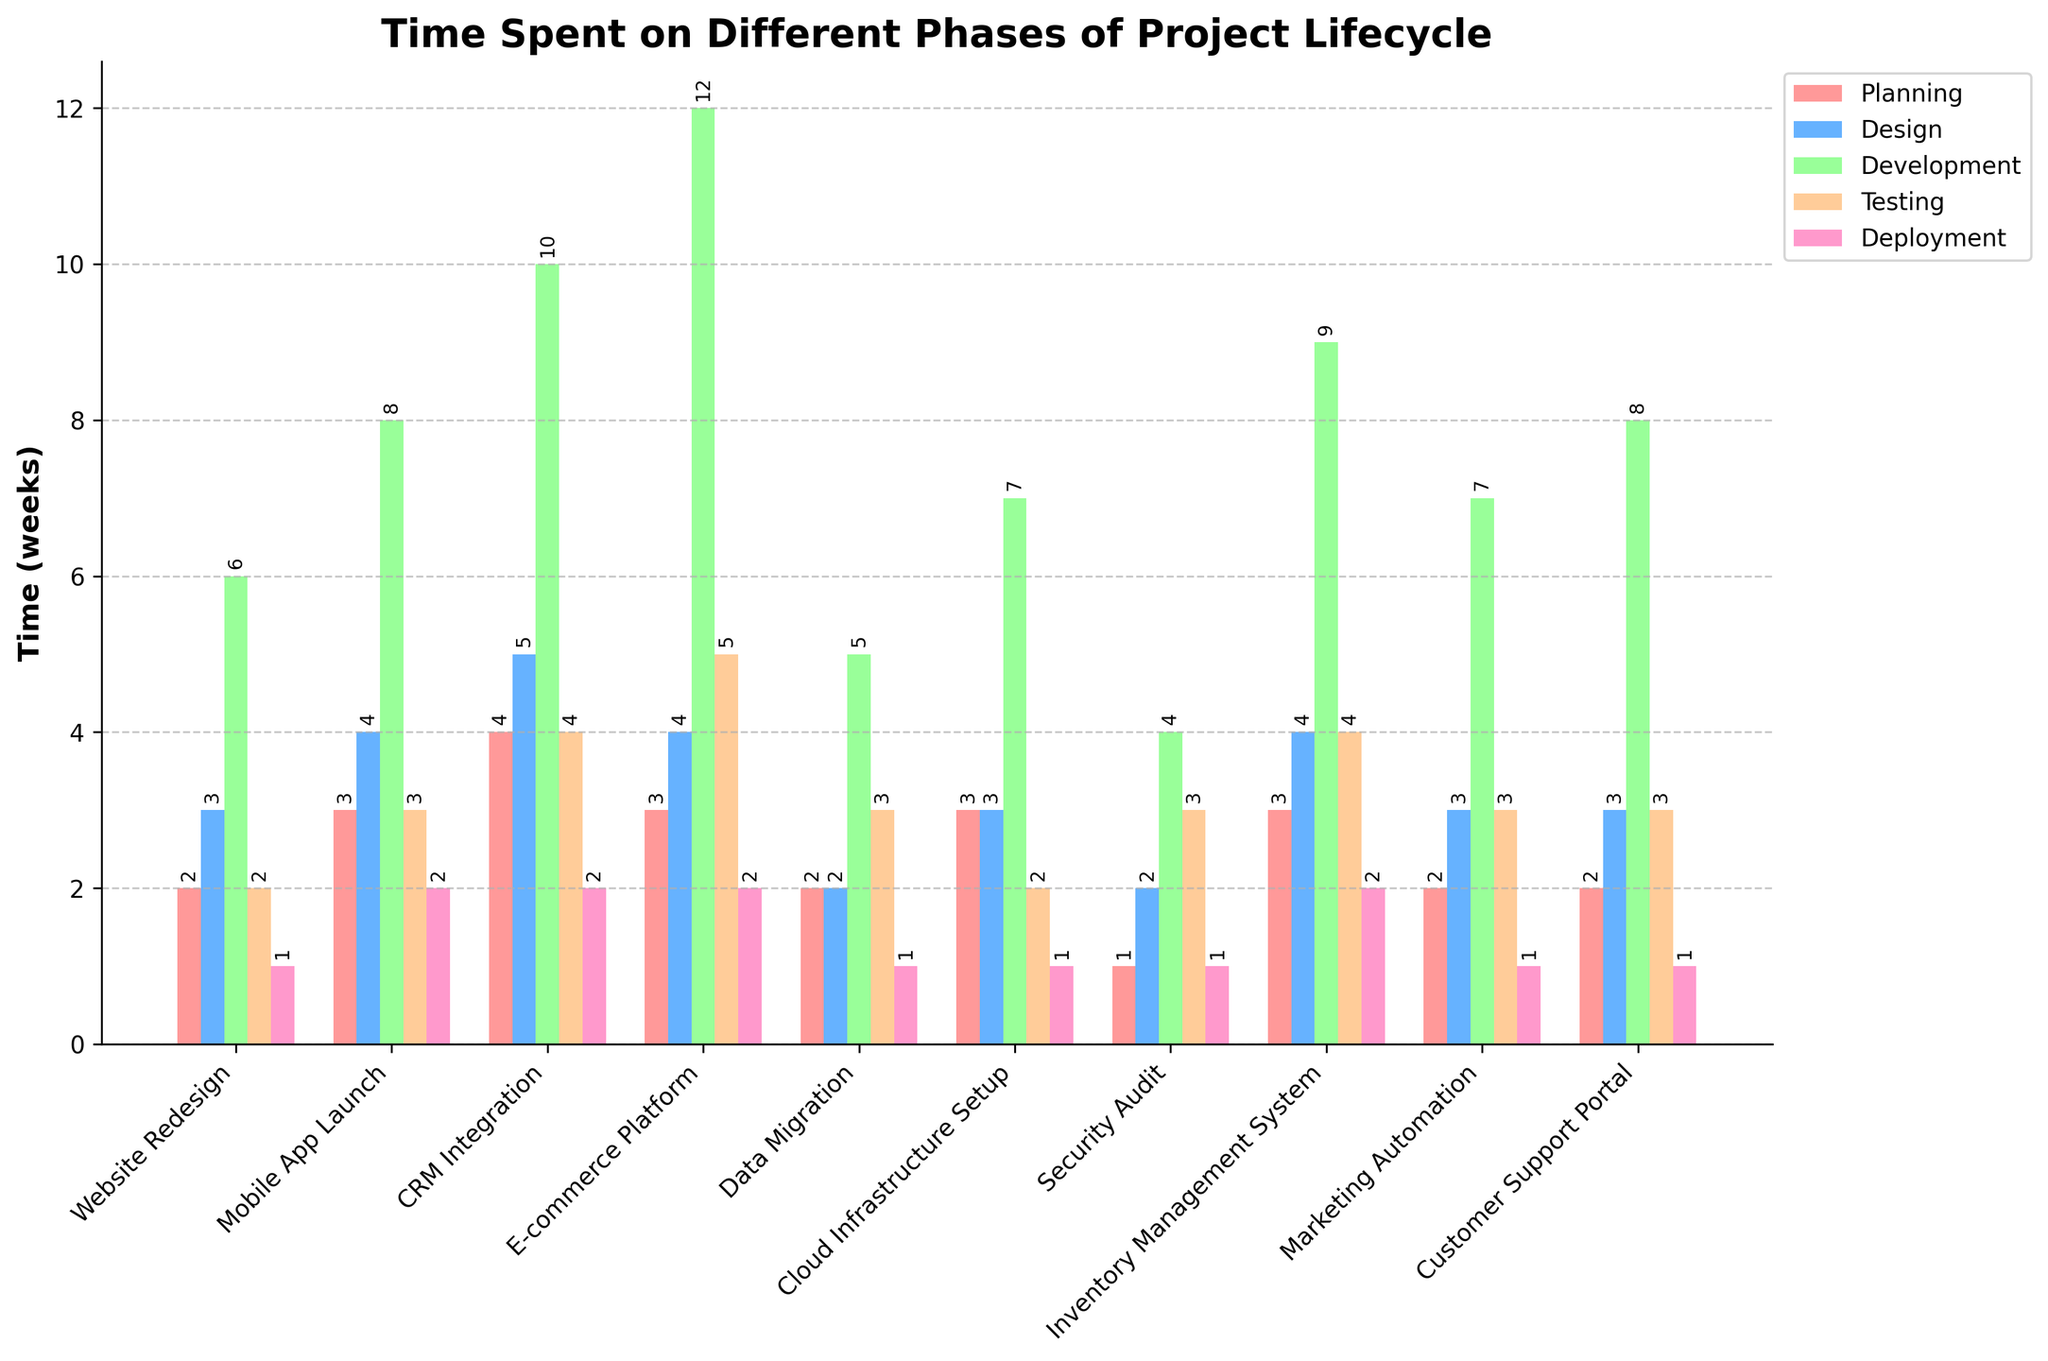What's the average time spent on the Development phase across all projects? First, sum the time spent on the Development phase for each project: 6 + 8 + 10 + 12 + 5 + 7 + 4 + 9 + 7 + 8 = 76. There are 10 projects, so we divide the total by 10. The average is 76/10 = 7.6 weeks.
Answer: 7.6 weeks Which project spent the most time on the Testing phase? By looking at the heights of the bars for the Testing phase, the project 'E-commerce Platform' has the tallest bar at 5 weeks.
Answer: E-commerce Platform How does the time spent on Deployment compare between 'Website Redesign' and 'Mobile App Launch'? The height of the Deployment bar for 'Website Redesign' is 1 week, and for 'Mobile App Launch' it is 2 weeks. So, 'Mobile App Launch' spent 1 week more on Deployment.
Answer: Mobile App Launch spent 1 week more Which phase has the most consistent time spent across all projects? By observing the bars, the Deployment phase has the most consistent height across all projects, varying between 1 and 2 weeks.
Answer: Deployment How many weeks were spent on the Planning phase for projects that also spent more than 3 weeks on the Testing phase? Projects 'CRM Integration' (4+5=9 weeks), 'E-commerce Platform' (3+5=8 weeks), and 'Inventory Management System' (3+4=7 weeks) spent more than 3 weeks on Testing. Summing the Planning times for these projects: 4 + 3 + 3 = 10 weeks.
Answer: 10 weeks What's the total time spent on 'Cloud Infrastructure Setup'? Add the time for each phase: Planning (3) + Design (3) + Development (7) + Testing (2) + Deployment (1). The total is 3+3+7+2+1 = 16 weeks.
Answer: 16 weeks Which project has the shortest time spent on the Development phase? By observing the bars for the Development phase, 'Security Audit' has the shortest bar with 4 weeks.
Answer: Security Audit What is the difference in time spent on Design between 'Marketing Automation' and 'CRM Integration'? The time spent on Design for 'Marketing Automation' is 3 weeks, and for 'CRM Integration' it is 5 weeks. The difference is 5 - 3 = 2 weeks.
Answer: 2 weeks How does the time spent on Testing for 'Website Redesign' compare to the time spent on the entire lifecycle of 'Security Audit'? 'Website Redesign' spent 2 weeks on Testing. The entire lifecycle of 'Security Audit': Planning (1) + Design (2) + Development (4) + Testing (3) + Deployment (1) = 11 weeks. So, 'Website Redesign' spent 9 weeks less on Testing compared to the entire lifecycle of 'Security Audit'.
Answer: 9 weeks less What is the highest time spent on any phase for 'Customer Support Portal'? The phases and their times for 'Customer Support Portal' are: Planning (2), Design (3), Development (8), Testing (3), Deployment (1). The highest time spent is 8 weeks on Development.
Answer: 8 weeks 